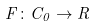Convert formula to latex. <formula><loc_0><loc_0><loc_500><loc_500>F \colon C _ { 0 } \rightarrow R</formula> 